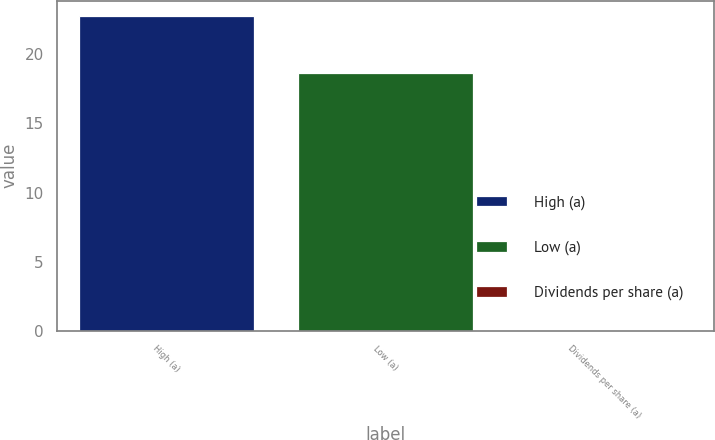Convert chart. <chart><loc_0><loc_0><loc_500><loc_500><bar_chart><fcel>High (a)<fcel>Low (a)<fcel>Dividends per share (a)<nl><fcel>22.74<fcel>18.65<fcel>0.05<nl></chart> 